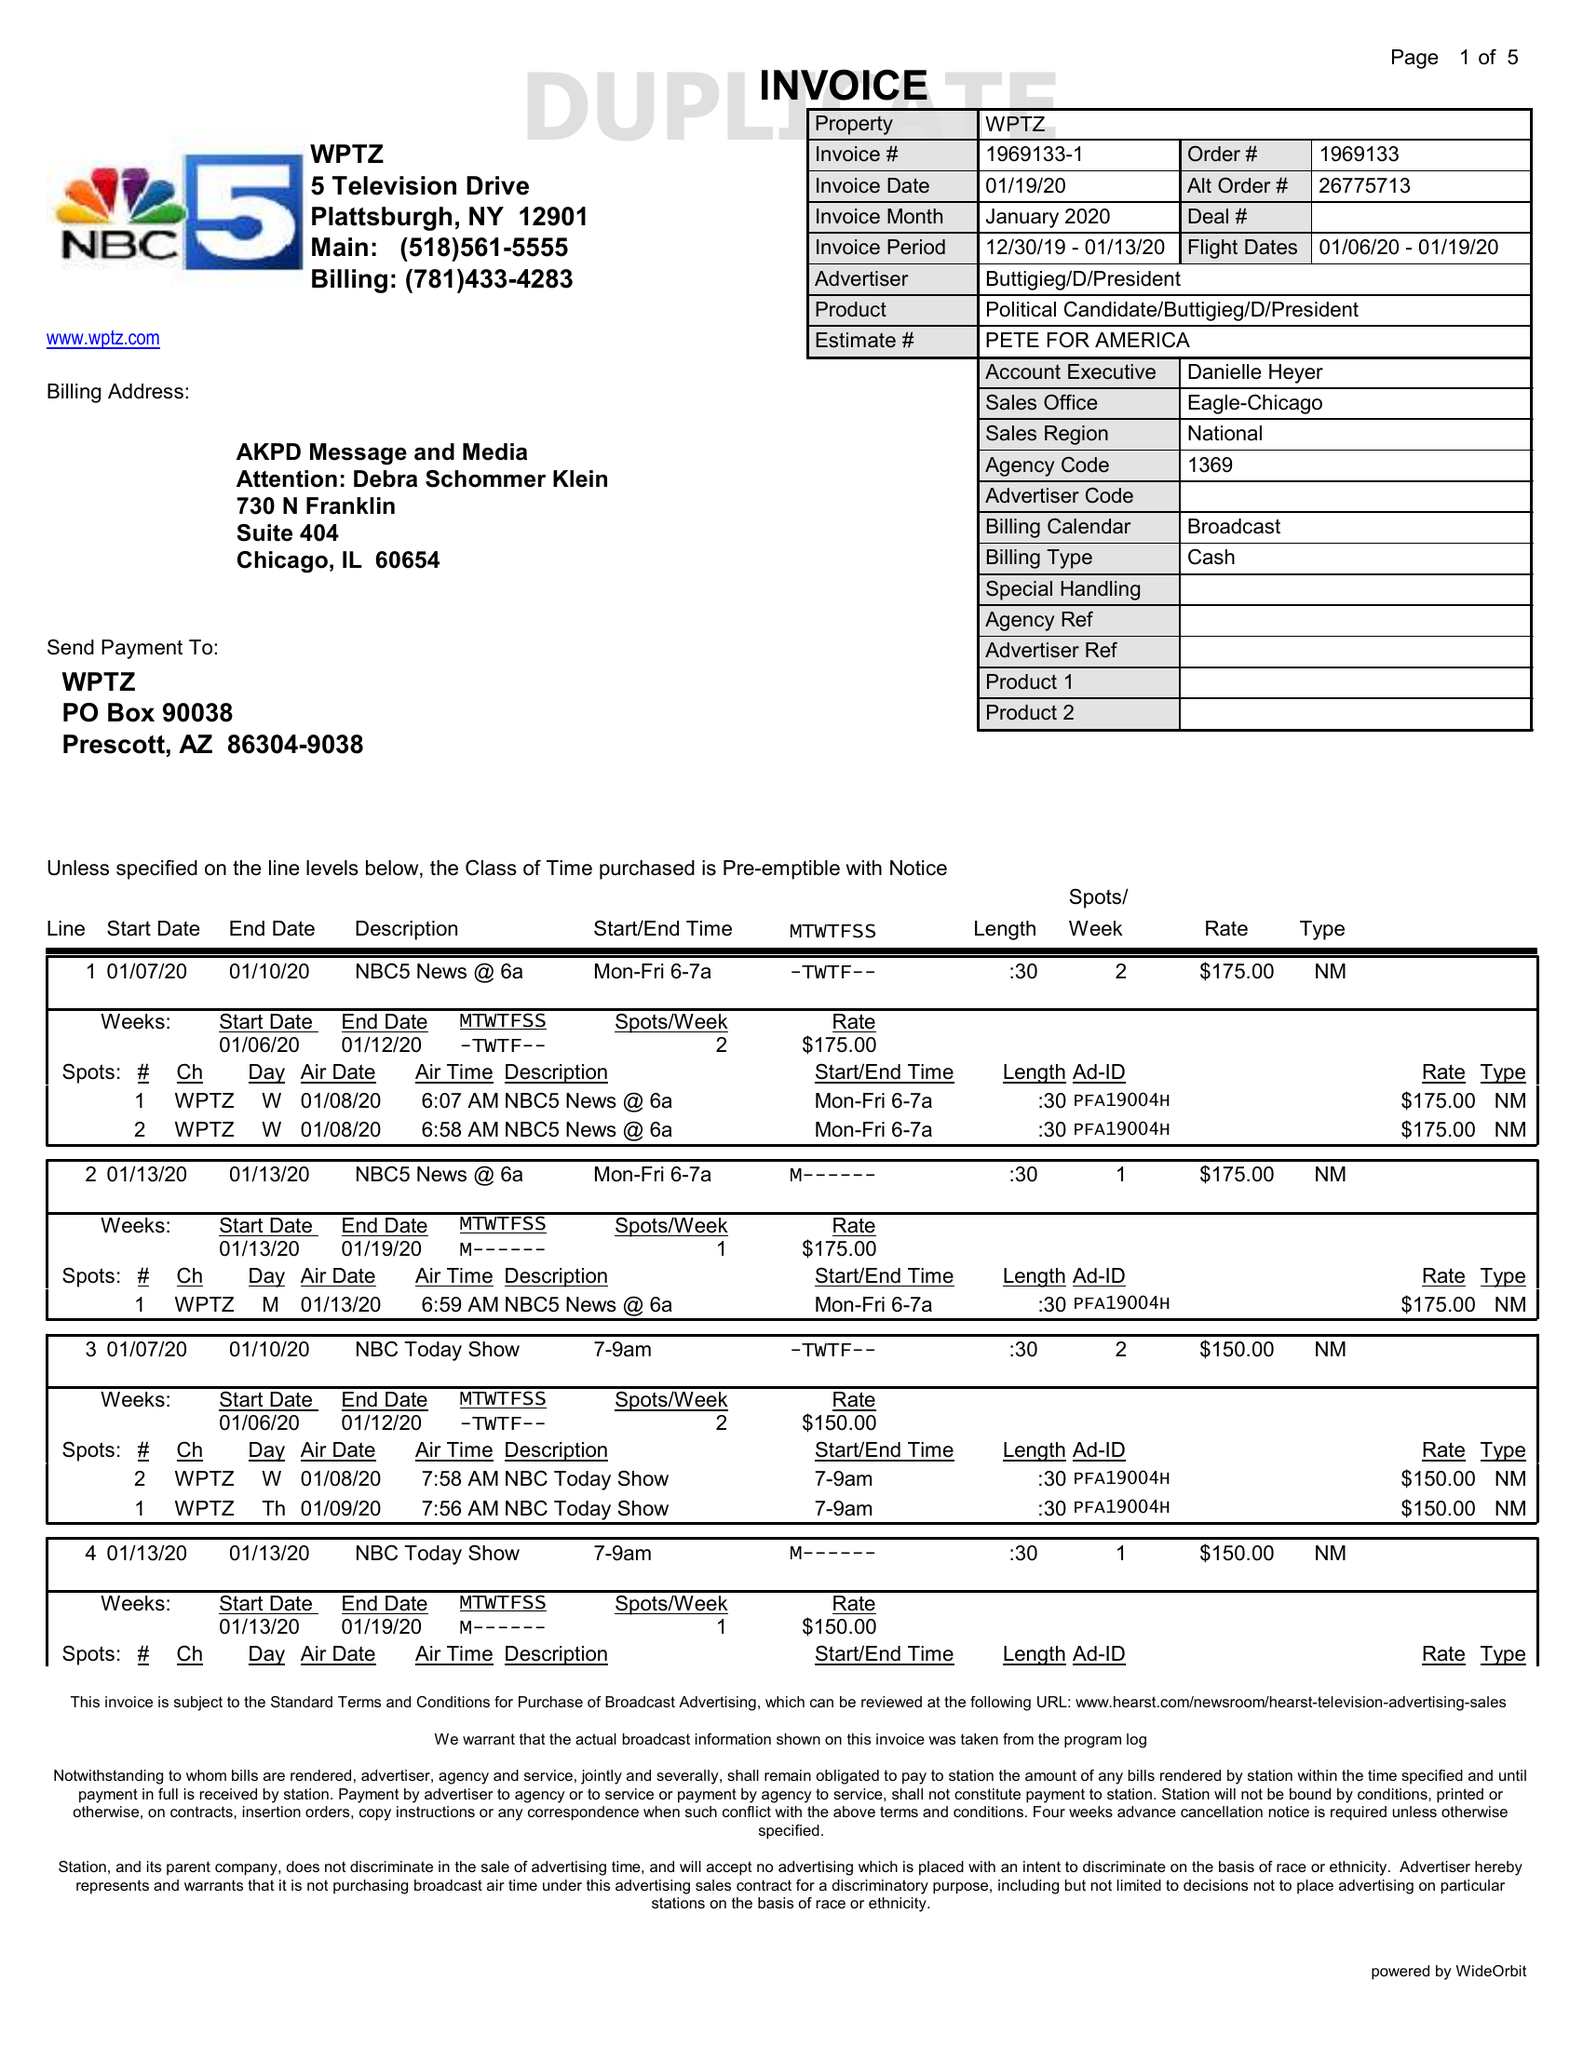What is the value for the advertiser?
Answer the question using a single word or phrase. BUTTIGIEG/D/PRESIDENT 